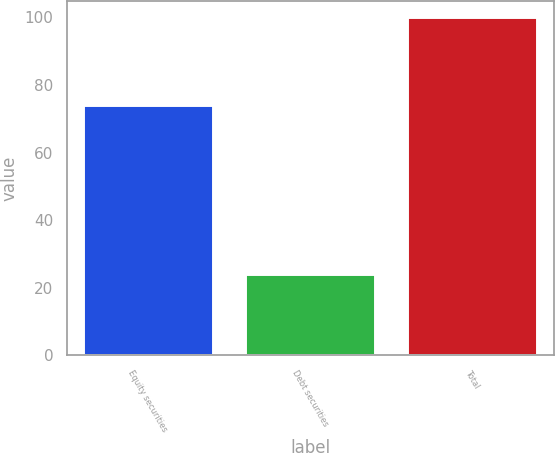Convert chart to OTSL. <chart><loc_0><loc_0><loc_500><loc_500><bar_chart><fcel>Equity securities<fcel>Debt securities<fcel>Total<nl><fcel>74<fcel>24<fcel>100<nl></chart> 